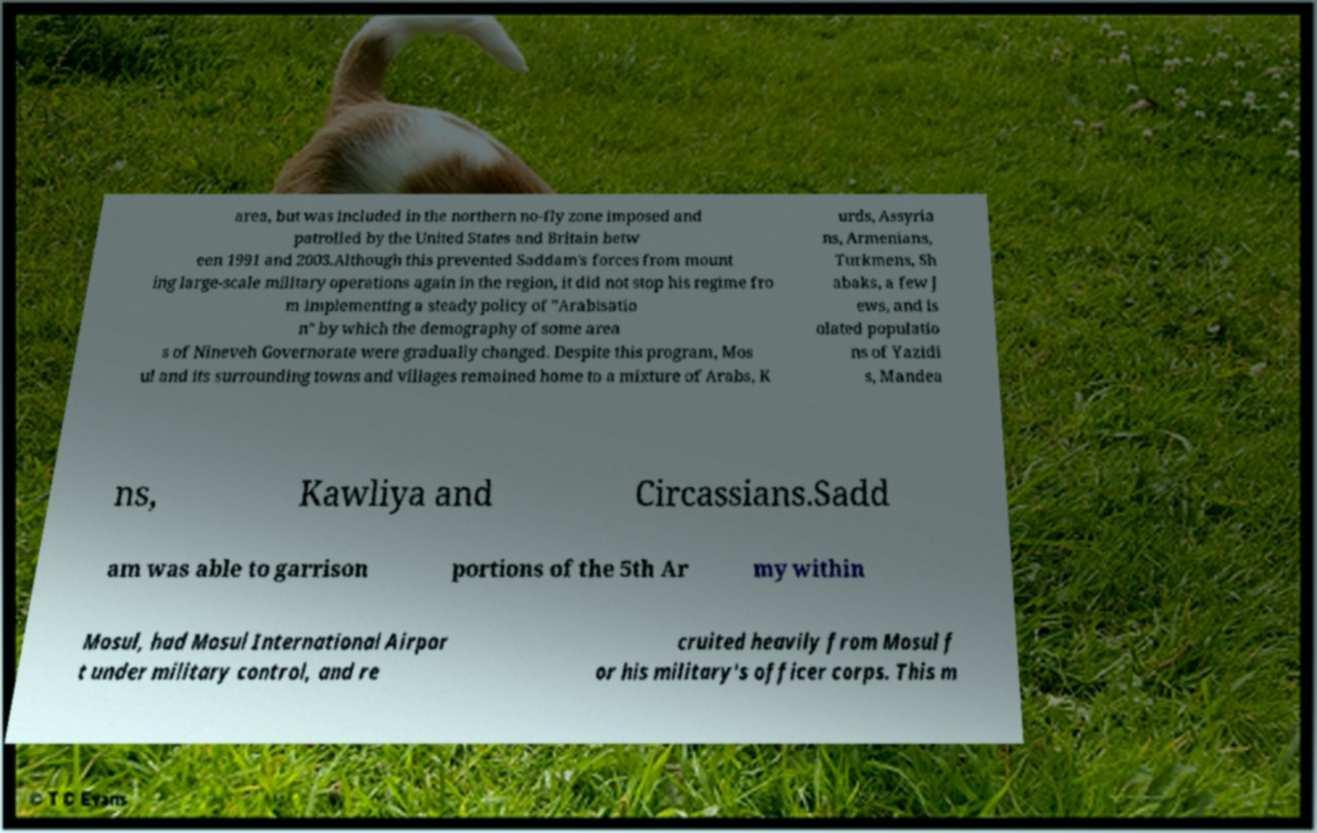Please identify and transcribe the text found in this image. area, but was included in the northern no-fly zone imposed and patrolled by the United States and Britain betw een 1991 and 2003.Although this prevented Saddam's forces from mount ing large-scale military operations again in the region, it did not stop his regime fro m implementing a steady policy of "Arabisatio n" by which the demography of some area s of Nineveh Governorate were gradually changed. Despite this program, Mos ul and its surrounding towns and villages remained home to a mixture of Arabs, K urds, Assyria ns, Armenians, Turkmens, Sh abaks, a few J ews, and is olated populatio ns of Yazidi s, Mandea ns, Kawliya and Circassians.Sadd am was able to garrison portions of the 5th Ar my within Mosul, had Mosul International Airpor t under military control, and re cruited heavily from Mosul f or his military's officer corps. This m 